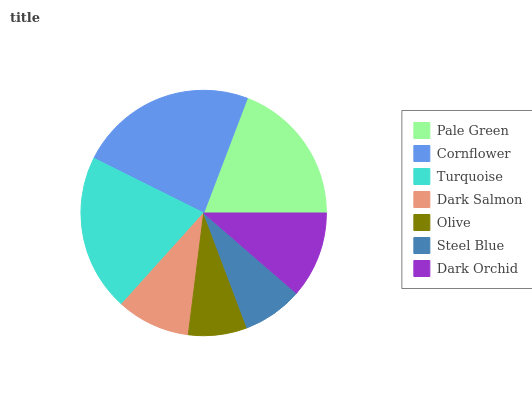Is Olive the minimum?
Answer yes or no. Yes. Is Cornflower the maximum?
Answer yes or no. Yes. Is Turquoise the minimum?
Answer yes or no. No. Is Turquoise the maximum?
Answer yes or no. No. Is Cornflower greater than Turquoise?
Answer yes or no. Yes. Is Turquoise less than Cornflower?
Answer yes or no. Yes. Is Turquoise greater than Cornflower?
Answer yes or no. No. Is Cornflower less than Turquoise?
Answer yes or no. No. Is Dark Orchid the high median?
Answer yes or no. Yes. Is Dark Orchid the low median?
Answer yes or no. Yes. Is Cornflower the high median?
Answer yes or no. No. Is Dark Salmon the low median?
Answer yes or no. No. 